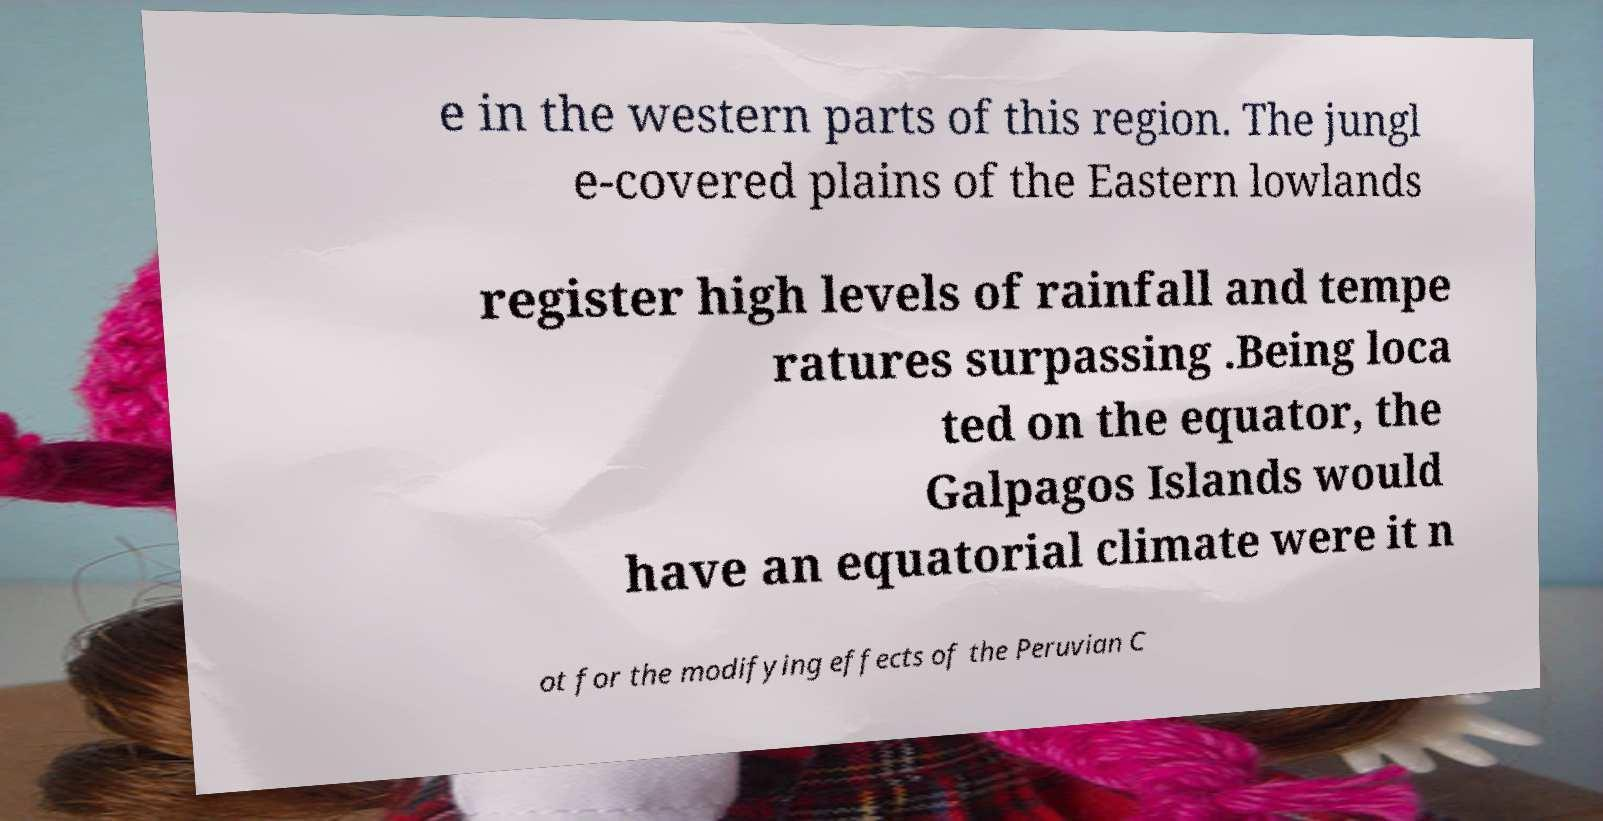Can you read and provide the text displayed in the image?This photo seems to have some interesting text. Can you extract and type it out for me? e in the western parts of this region. The jungl e-covered plains of the Eastern lowlands register high levels of rainfall and tempe ratures surpassing .Being loca ted on the equator, the Galpagos Islands would have an equatorial climate were it n ot for the modifying effects of the Peruvian C 